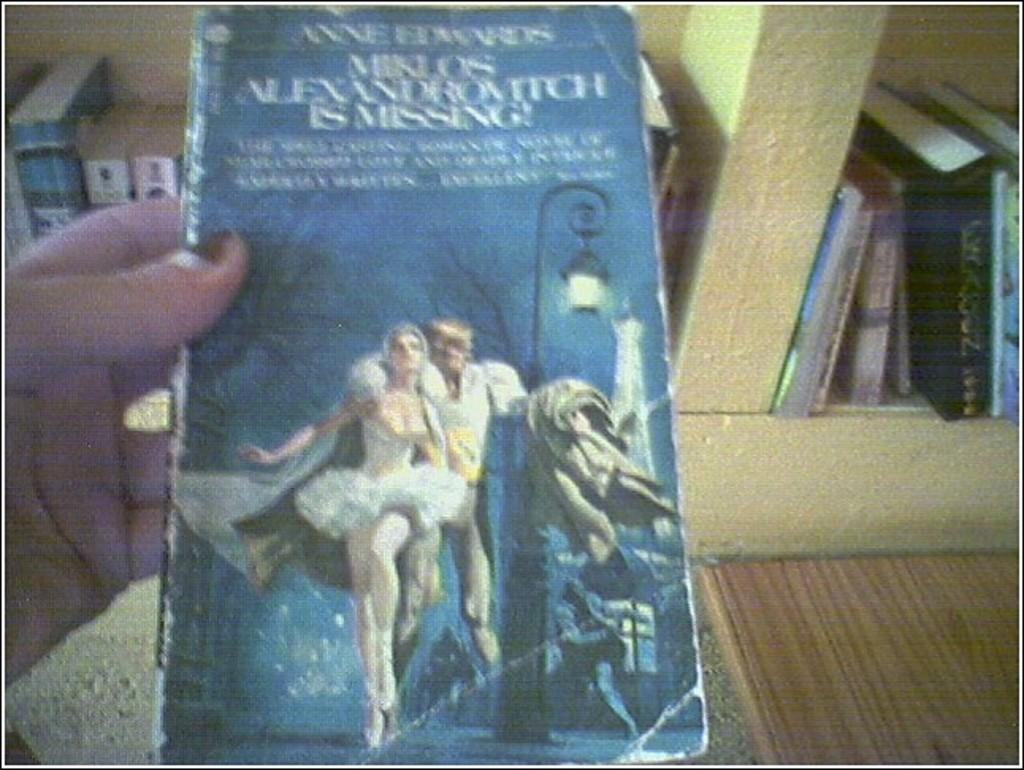Provide a one-sentence caption for the provided image. A book that is by a author named Anne Edwards. 